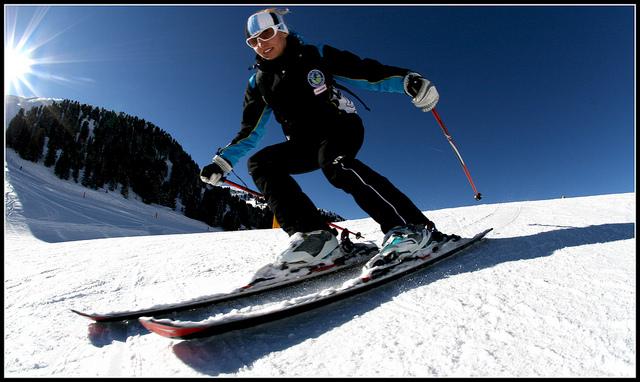What sport is this person engaging in?
Be succinct. Skiing. Is this a man or a woman?
Concise answer only. Woman. What color is the skier's visor?
Give a very brief answer. White. What time of day was this picture taken?
Be succinct. Afternoon. 